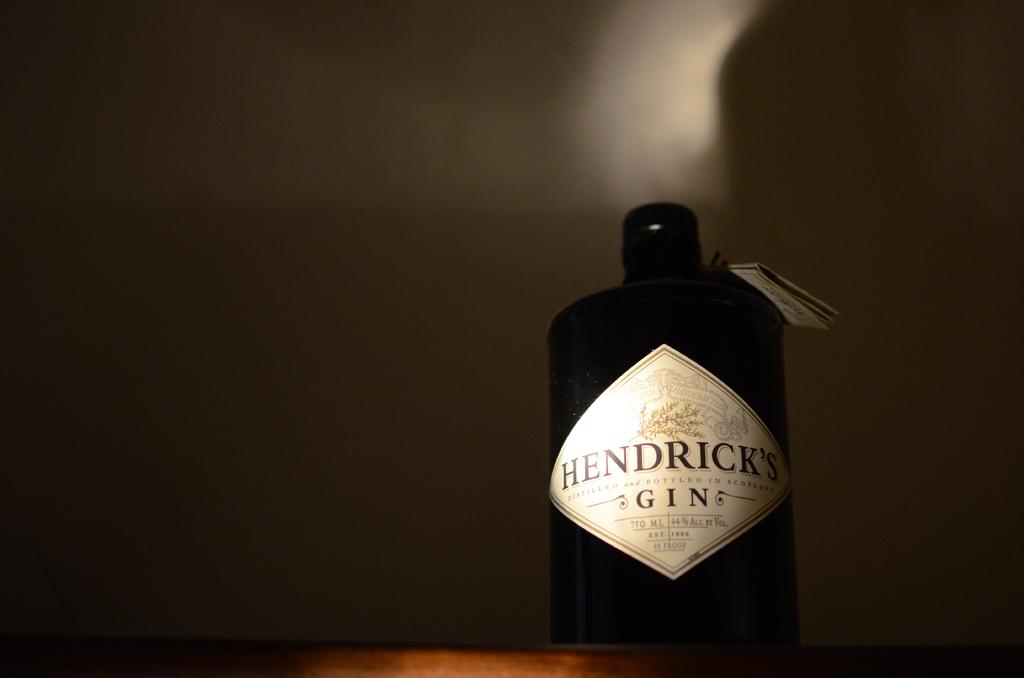What brand of gin is this?
Your answer should be very brief. Hendrick's. What kind of alcohol is this?
Your answer should be very brief. Gin. 